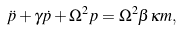Convert formula to latex. <formula><loc_0><loc_0><loc_500><loc_500>\ddot { p } + \gamma \dot { p } + \Omega ^ { 2 } p = \Omega ^ { 2 } \beta \kappa m ,</formula> 